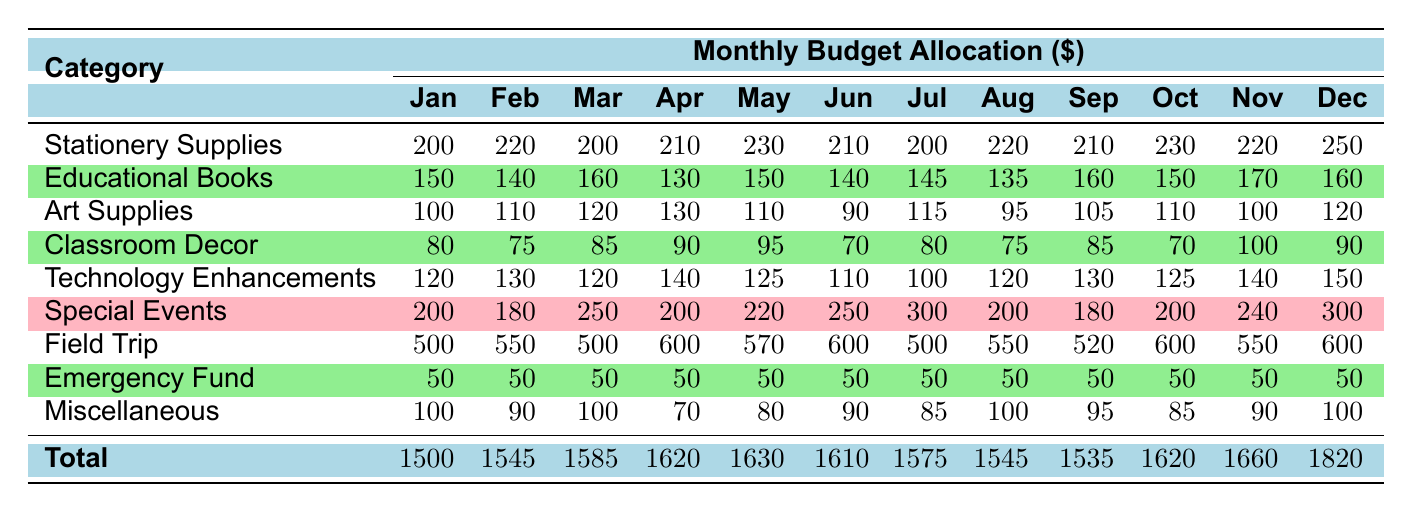What is the total budget allocation for May? To find the total budget allocation for May, we can look at the last row of the May column. The values for May are Stationery Supplies (230), Educational Books (150), Art Supplies (110), Classroom Decor (95), Technology Enhancements (125), Spring Concert (220), Field Trip (570), Emergency Fund (50), and Miscellaneous (80). Adding these values gives us 230 + 150 + 110 + 95 + 125 + 220 + 570 + 50 + 80 = 1630.
Answer: 1630 Which category had the highest allocation in December? In December, we can look at each category's value: Stationery Supplies (250), Educational Books (160), Art Supplies (120), Classroom Decor (90), Technology Enhancements (150), Christmas Party (300), Field Trip (600), Emergency Fund (50), and Miscellaneous (100). The highest value is the Field Trip at 600.
Answer: Field Trip Was there a decrease in budget for Classroom Decor from January to February? In January, the allocation for Classroom Decor was 80, and in February, it was 75. Since 75 is less than 80, it indicates a decrease.
Answer: Yes What is the average amount allocated to Art Supplies over the year? To calculate the average amount allocated to Art Supplies, we sum the Art Supplies amounts from each month: (100 + 110 + 120 + 130 + 110 + 90 + 115 + 95 + 105 + 110 + 100 + 120) = 1,295. There are 12 months, so we divide the total by 12: 1295 / 12 = 107.92.
Answer: 107.92 Did the total budget allocation increase or decrease from November to December? The total for November is 1660, and for December, it is 1820. To see the change, we subtract the November total from the December total: 1820 - 1660 = 160, which is a positive number, indicating an increase in budget allocation.
Answer: Increase What is the combined budget for Special Events and Field Trips in April? In April, the budget for Special Events (Easter Celebration) is 200 and for Field Trips is 600. Adding these values together gives us 200 + 600 = 800.
Answer: 800 Which month had the highest allocation for Technology Enhancements? By comparing the Technology Enhancements values across the months, we see that January has 120, February has 130, March has 120, April has 140, May has 125, June has 110, July has 100, August has 120, September has 130, October has 125, November has 140, and December has 150. The highest value is in December at 150.
Answer: December In which month was the total budget allocation the lowest? Looking at the total budgets for each month: January (1500), February (1545), March (1585), April (1620), May (1630), June (1610), July (1575), August (1545), September (1535), October (1620), November (1660), and December (1820). The lowest total is for January at 1500.
Answer: January What was the increase in budget allocation for Educational Books from February to March? The budget for Educational Books in February is 140, and in March, it is 160. The increase can be found by subtracting the February amount from the March amount: 160 - 140 = 20.
Answer: 20 